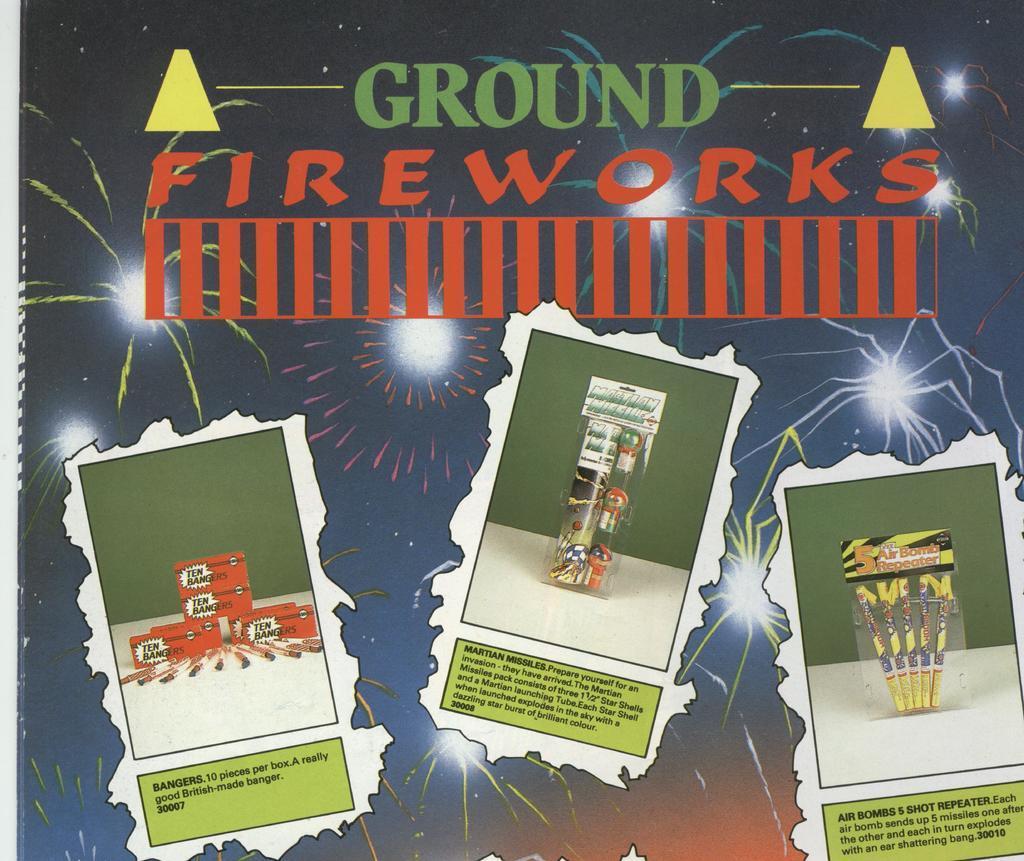Describe this image in one or two sentences. This is a poster and here we can see some text and images of crackers and boxes. 